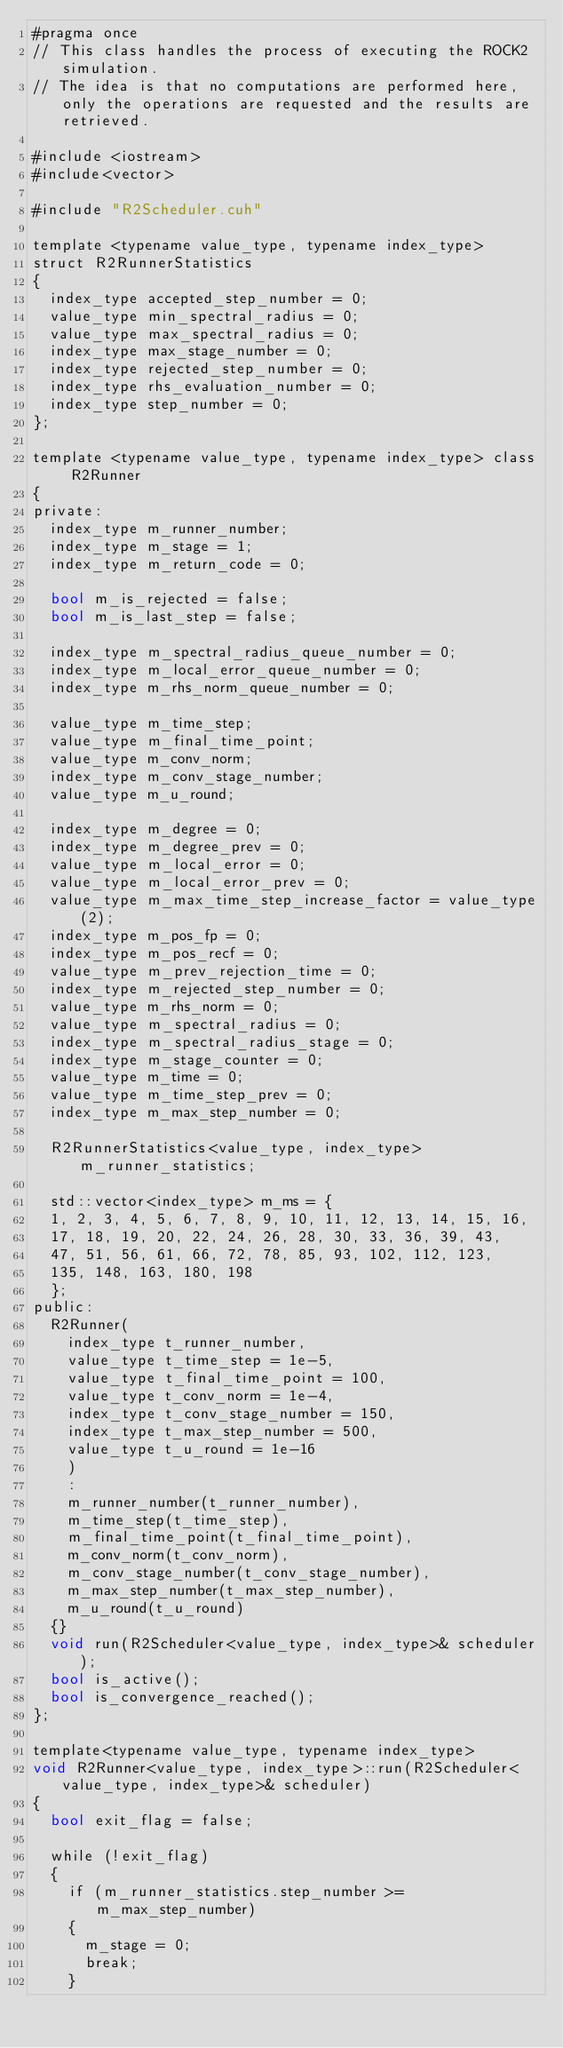Convert code to text. <code><loc_0><loc_0><loc_500><loc_500><_Cuda_>#pragma once
// This class handles the process of executing the ROCK2 simulation. 
// The idea is that no computations are performed here, only the operations are requested and the results are retrieved.

#include <iostream>
#include<vector>

#include "R2Scheduler.cuh"

template <typename value_type, typename index_type>
struct R2RunnerStatistics
{
	index_type accepted_step_number = 0;
	value_type min_spectral_radius = 0;
	value_type max_spectral_radius = 0;
	index_type max_stage_number = 0;
	index_type rejected_step_number = 0;
	index_type rhs_evaluation_number = 0;
	index_type step_number = 0;
};

template <typename value_type, typename index_type> class R2Runner
{
private:
	index_type m_runner_number;
	index_type m_stage = 1;
	index_type m_return_code = 0;

	bool m_is_rejected = false;
	bool m_is_last_step = false;

	index_type m_spectral_radius_queue_number = 0;
	index_type m_local_error_queue_number = 0;
	index_type m_rhs_norm_queue_number = 0;

	value_type m_time_step;
	value_type m_final_time_point;
	value_type m_conv_norm;
	index_type m_conv_stage_number;
	value_type m_u_round;

	index_type m_degree = 0;
	index_type m_degree_prev = 0;
	value_type m_local_error = 0;
	value_type m_local_error_prev = 0;
	value_type m_max_time_step_increase_factor = value_type(2);
	index_type m_pos_fp = 0;
	index_type m_pos_recf = 0;
	value_type m_prev_rejection_time = 0;
	index_type m_rejected_step_number = 0;
	value_type m_rhs_norm = 0;
	value_type m_spectral_radius = 0;
	index_type m_spectral_radius_stage = 0;
	index_type m_stage_counter = 0;
	value_type m_time = 0;
	value_type m_time_step_prev = 0;
	index_type m_max_step_number = 0;

	R2RunnerStatistics<value_type, index_type> m_runner_statistics;

	std::vector<index_type> m_ms = {
	1, 2, 3, 4, 5, 6, 7, 8, 9, 10, 11, 12, 13, 14, 15, 16,
	17, 18, 19, 20, 22, 24, 26, 28, 30, 33, 36, 39, 43,
	47, 51, 56, 61, 66, 72, 78, 85, 93, 102, 112, 123,
	135, 148, 163, 180, 198
	};
public:
	R2Runner(
		index_type t_runner_number,
		value_type t_time_step = 1e-5,
		value_type t_final_time_point = 100,
		value_type t_conv_norm = 1e-4,
		index_type t_conv_stage_number = 150,
		index_type t_max_step_number = 500,
		value_type t_u_round = 1e-16
		)
		: 
		m_runner_number(t_runner_number), 
		m_time_step(t_time_step), 
		m_final_time_point(t_final_time_point),
		m_conv_norm(t_conv_norm),
		m_conv_stage_number(t_conv_stage_number),
		m_max_step_number(t_max_step_number),
		m_u_round(t_u_round)
	{}
	void run(R2Scheduler<value_type, index_type>& scheduler);
	bool is_active();
	bool is_convergence_reached();
};

template<typename value_type, typename index_type>
void R2Runner<value_type, index_type>::run(R2Scheduler<value_type, index_type>& scheduler)
{
	bool exit_flag = false;

	while (!exit_flag)
	{
		if (m_runner_statistics.step_number >= m_max_step_number)
		{
			m_stage = 0;
			break;
		}
</code> 